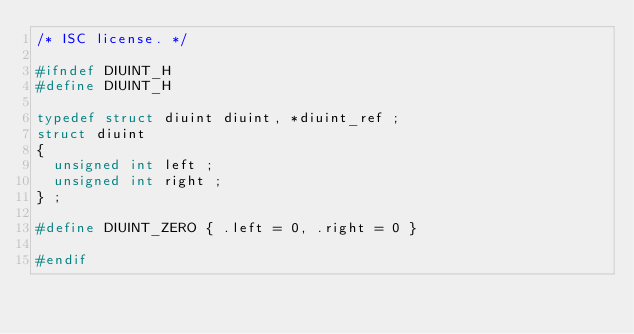<code> <loc_0><loc_0><loc_500><loc_500><_C_>/* ISC license. */

#ifndef DIUINT_H
#define DIUINT_H

typedef struct diuint diuint, *diuint_ref ;
struct diuint
{
  unsigned int left ;
  unsigned int right ;
} ;

#define DIUINT_ZERO { .left = 0, .right = 0 }

#endif
</code> 